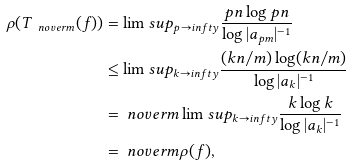<formula> <loc_0><loc_0><loc_500><loc_500>\rho ( T _ { \ n o v e r m } ( f ) ) & = \lim s u p _ { p \to i n f t y } \frac { p n \log p n } { \log | a _ { p m } | ^ { - 1 } } \\ & \leq \lim s u p _ { k \to i n f t y } \frac { ( k n / m ) \log ( k n / m ) } { \log | a _ { k } | ^ { - 1 } } \\ & = \ n o v e r m \lim s u p _ { k \to i n f t y } \frac { k \log k } { \log | a _ { k } | ^ { - 1 } } \\ & = \ n o v e r m \rho ( f ) ,</formula> 